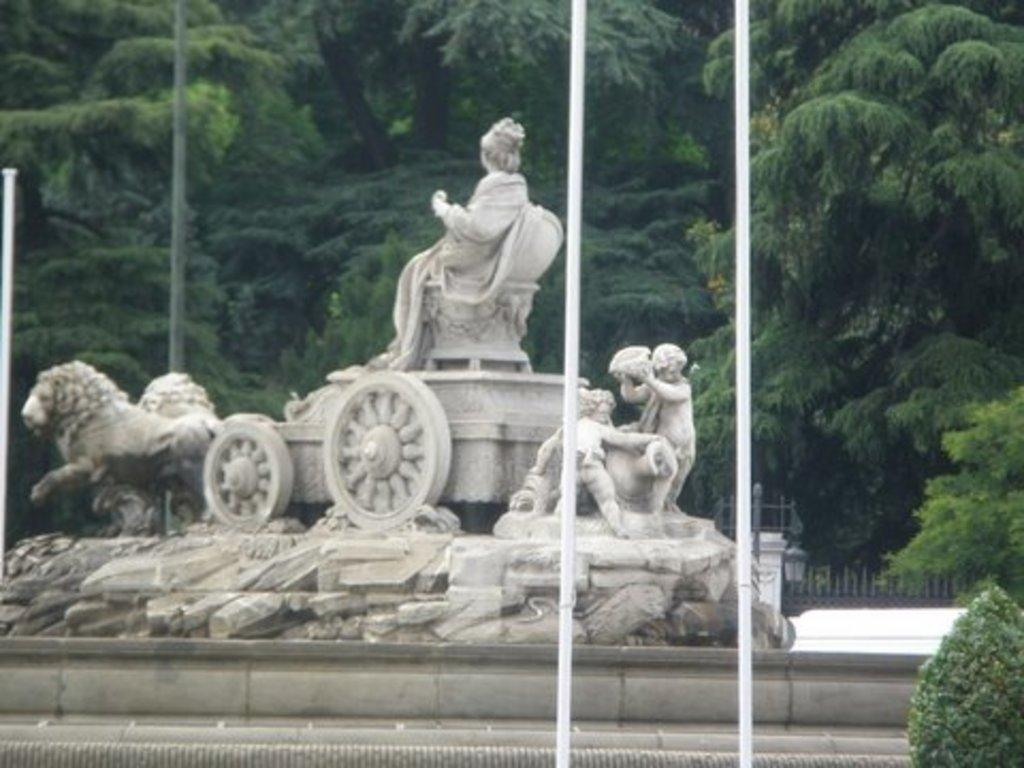What type of natural elements can be seen in the image? There are trees in the image. What man-made objects are present in the image? There are poles in the image. What is the main subject in the middle of the image? There is a sculpture in the middle of the image. Where is the plant located in the image? There is a plant in the bottom right of the image. Can you tell me how many times the sculpture has been copied in the image? There is no indication in the image that the sculpture has been copied or duplicated; it appears to be a single, unique sculpture. 